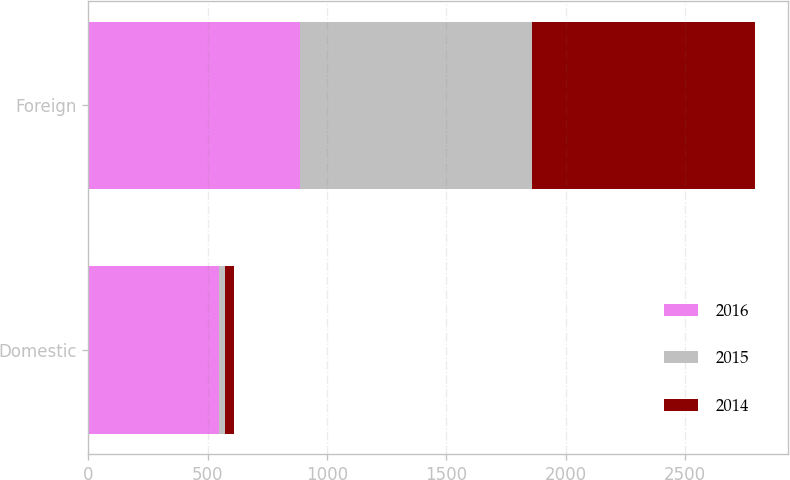Convert chart to OTSL. <chart><loc_0><loc_0><loc_500><loc_500><stacked_bar_chart><ecel><fcel>Domestic<fcel>Foreign<nl><fcel>2016<fcel>546.4<fcel>888.1<nl><fcel>2015<fcel>27<fcel>968.8<nl><fcel>2014<fcel>34.7<fcel>933.5<nl></chart> 